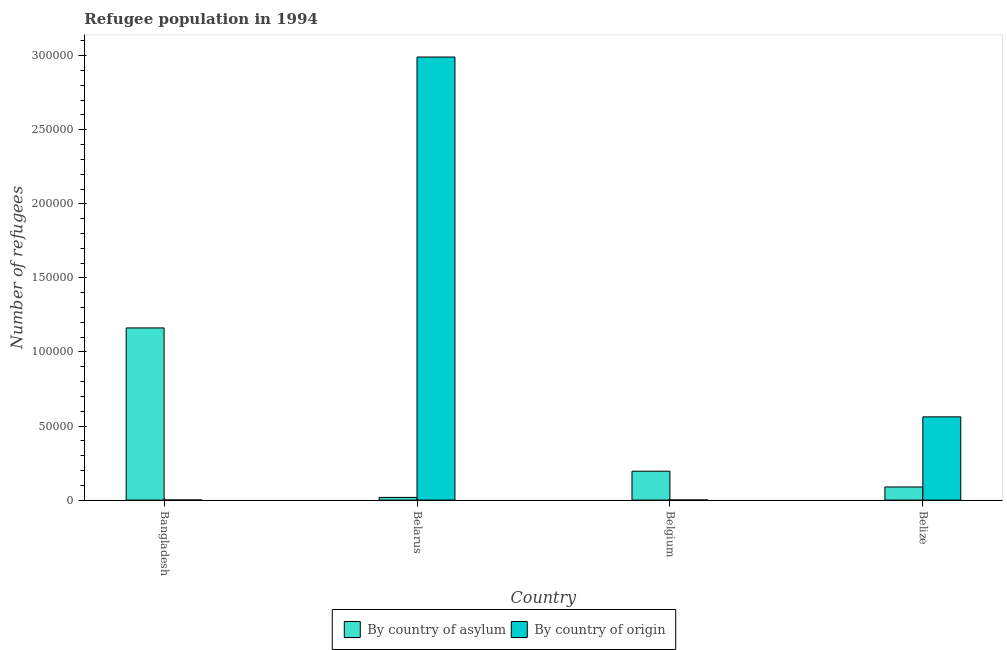How many groups of bars are there?
Ensure brevity in your answer.  4. Are the number of bars per tick equal to the number of legend labels?
Your answer should be compact. Yes. How many bars are there on the 3rd tick from the left?
Keep it short and to the point. 2. How many bars are there on the 3rd tick from the right?
Your response must be concise. 2. What is the label of the 1st group of bars from the left?
Provide a short and direct response. Bangladesh. What is the number of refugees by country of asylum in Belgium?
Offer a very short reply. 1.95e+04. Across all countries, what is the maximum number of refugees by country of origin?
Make the answer very short. 2.99e+05. Across all countries, what is the minimum number of refugees by country of origin?
Your response must be concise. 60. In which country was the number of refugees by country of asylum maximum?
Your response must be concise. Bangladesh. What is the total number of refugees by country of asylum in the graph?
Provide a succinct answer. 1.46e+05. What is the difference between the number of refugees by country of asylum in Belarus and that in Belgium?
Provide a succinct answer. -1.77e+04. What is the difference between the number of refugees by country of origin in Belarus and the number of refugees by country of asylum in Belgium?
Keep it short and to the point. 2.80e+05. What is the average number of refugees by country of asylum per country?
Your answer should be very brief. 3.66e+04. What is the difference between the number of refugees by country of origin and number of refugees by country of asylum in Belarus?
Ensure brevity in your answer.  2.97e+05. In how many countries, is the number of refugees by country of asylum greater than 240000 ?
Make the answer very short. 0. What is the ratio of the number of refugees by country of asylum in Belarus to that in Belize?
Make the answer very short. 0.21. Is the number of refugees by country of origin in Belgium less than that in Belize?
Provide a short and direct response. Yes. What is the difference between the highest and the second highest number of refugees by country of origin?
Provide a short and direct response. 2.43e+05. What is the difference between the highest and the lowest number of refugees by country of asylum?
Offer a very short reply. 1.14e+05. Is the sum of the number of refugees by country of origin in Belarus and Belize greater than the maximum number of refugees by country of asylum across all countries?
Provide a short and direct response. Yes. What does the 1st bar from the left in Belize represents?
Provide a succinct answer. By country of asylum. What does the 2nd bar from the right in Belarus represents?
Offer a very short reply. By country of asylum. Are all the bars in the graph horizontal?
Ensure brevity in your answer.  No. What is the difference between two consecutive major ticks on the Y-axis?
Offer a very short reply. 5.00e+04. Are the values on the major ticks of Y-axis written in scientific E-notation?
Your response must be concise. No. Does the graph contain any zero values?
Your answer should be very brief. No. How are the legend labels stacked?
Provide a short and direct response. Horizontal. What is the title of the graph?
Provide a short and direct response. Refugee population in 1994. Does "Exports of goods" appear as one of the legend labels in the graph?
Your answer should be compact. No. What is the label or title of the X-axis?
Give a very brief answer. Country. What is the label or title of the Y-axis?
Provide a short and direct response. Number of refugees. What is the Number of refugees in By country of asylum in Bangladesh?
Your answer should be very brief. 1.16e+05. What is the Number of refugees in By country of origin in Bangladesh?
Keep it short and to the point. 60. What is the Number of refugees in By country of asylum in Belarus?
Give a very brief answer. 1822. What is the Number of refugees in By country of origin in Belarus?
Provide a short and direct response. 2.99e+05. What is the Number of refugees in By country of asylum in Belgium?
Your answer should be compact. 1.95e+04. What is the Number of refugees in By country of origin in Belgium?
Keep it short and to the point. 75. What is the Number of refugees of By country of asylum in Belize?
Your response must be concise. 8857. What is the Number of refugees in By country of origin in Belize?
Provide a short and direct response. 5.62e+04. Across all countries, what is the maximum Number of refugees in By country of asylum?
Ensure brevity in your answer.  1.16e+05. Across all countries, what is the maximum Number of refugees in By country of origin?
Keep it short and to the point. 2.99e+05. Across all countries, what is the minimum Number of refugees in By country of asylum?
Your answer should be compact. 1822. What is the total Number of refugees of By country of asylum in the graph?
Give a very brief answer. 1.46e+05. What is the total Number of refugees in By country of origin in the graph?
Give a very brief answer. 3.55e+05. What is the difference between the Number of refugees in By country of asylum in Bangladesh and that in Belarus?
Offer a terse response. 1.14e+05. What is the difference between the Number of refugees in By country of origin in Bangladesh and that in Belarus?
Provide a succinct answer. -2.99e+05. What is the difference between the Number of refugees of By country of asylum in Bangladesh and that in Belgium?
Keep it short and to the point. 9.67e+04. What is the difference between the Number of refugees in By country of asylum in Bangladesh and that in Belize?
Your answer should be compact. 1.07e+05. What is the difference between the Number of refugees of By country of origin in Bangladesh and that in Belize?
Ensure brevity in your answer.  -5.61e+04. What is the difference between the Number of refugees in By country of asylum in Belarus and that in Belgium?
Your answer should be very brief. -1.77e+04. What is the difference between the Number of refugees in By country of origin in Belarus and that in Belgium?
Ensure brevity in your answer.  2.99e+05. What is the difference between the Number of refugees in By country of asylum in Belarus and that in Belize?
Provide a short and direct response. -7035. What is the difference between the Number of refugees of By country of origin in Belarus and that in Belize?
Offer a terse response. 2.43e+05. What is the difference between the Number of refugees in By country of asylum in Belgium and that in Belize?
Ensure brevity in your answer.  1.06e+04. What is the difference between the Number of refugees of By country of origin in Belgium and that in Belize?
Ensure brevity in your answer.  -5.61e+04. What is the difference between the Number of refugees in By country of asylum in Bangladesh and the Number of refugees in By country of origin in Belarus?
Make the answer very short. -1.83e+05. What is the difference between the Number of refugees of By country of asylum in Bangladesh and the Number of refugees of By country of origin in Belgium?
Make the answer very short. 1.16e+05. What is the difference between the Number of refugees in By country of asylum in Bangladesh and the Number of refugees in By country of origin in Belize?
Provide a succinct answer. 6.00e+04. What is the difference between the Number of refugees of By country of asylum in Belarus and the Number of refugees of By country of origin in Belgium?
Your answer should be compact. 1747. What is the difference between the Number of refugees of By country of asylum in Belarus and the Number of refugees of By country of origin in Belize?
Give a very brief answer. -5.44e+04. What is the difference between the Number of refugees in By country of asylum in Belgium and the Number of refugees in By country of origin in Belize?
Offer a terse response. -3.67e+04. What is the average Number of refugees of By country of asylum per country?
Your answer should be very brief. 3.66e+04. What is the average Number of refugees of By country of origin per country?
Provide a succinct answer. 8.89e+04. What is the difference between the Number of refugees of By country of asylum and Number of refugees of By country of origin in Bangladesh?
Provide a short and direct response. 1.16e+05. What is the difference between the Number of refugees in By country of asylum and Number of refugees in By country of origin in Belarus?
Ensure brevity in your answer.  -2.97e+05. What is the difference between the Number of refugees of By country of asylum and Number of refugees of By country of origin in Belgium?
Your answer should be compact. 1.94e+04. What is the difference between the Number of refugees in By country of asylum and Number of refugees in By country of origin in Belize?
Give a very brief answer. -4.73e+04. What is the ratio of the Number of refugees in By country of asylum in Bangladesh to that in Belarus?
Offer a terse response. 63.79. What is the ratio of the Number of refugees of By country of asylum in Bangladesh to that in Belgium?
Offer a very short reply. 5.96. What is the ratio of the Number of refugees in By country of asylum in Bangladesh to that in Belize?
Make the answer very short. 13.12. What is the ratio of the Number of refugees of By country of origin in Bangladesh to that in Belize?
Give a very brief answer. 0. What is the ratio of the Number of refugees in By country of asylum in Belarus to that in Belgium?
Give a very brief answer. 0.09. What is the ratio of the Number of refugees of By country of origin in Belarus to that in Belgium?
Offer a terse response. 3987.93. What is the ratio of the Number of refugees of By country of asylum in Belarus to that in Belize?
Keep it short and to the point. 0.21. What is the ratio of the Number of refugees of By country of origin in Belarus to that in Belize?
Your answer should be compact. 5.32. What is the ratio of the Number of refugees in By country of asylum in Belgium to that in Belize?
Offer a very short reply. 2.2. What is the ratio of the Number of refugees of By country of origin in Belgium to that in Belize?
Offer a terse response. 0. What is the difference between the highest and the second highest Number of refugees in By country of asylum?
Ensure brevity in your answer.  9.67e+04. What is the difference between the highest and the second highest Number of refugees of By country of origin?
Offer a terse response. 2.43e+05. What is the difference between the highest and the lowest Number of refugees in By country of asylum?
Provide a succinct answer. 1.14e+05. What is the difference between the highest and the lowest Number of refugees of By country of origin?
Provide a succinct answer. 2.99e+05. 